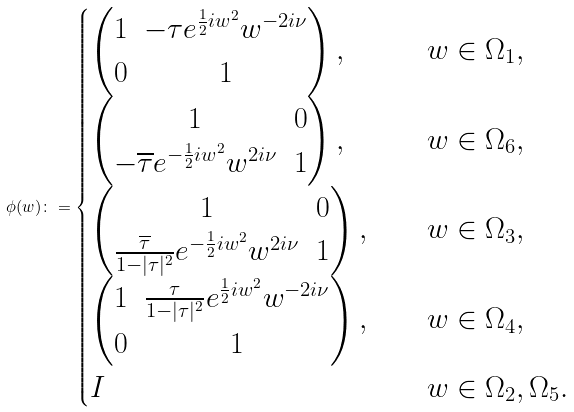Convert formula to latex. <formula><loc_0><loc_0><loc_500><loc_500>\phi ( w ) \colon = \begin{cases} \begin{pmatrix} 1 & - \tau e ^ { \frac { 1 } { 2 } i w ^ { 2 } } w ^ { - 2 i \nu } \\ 0 & 1 \end{pmatrix} , \quad & w \in \Omega _ { 1 } , \\ \begin{pmatrix} 1 & 0 \\ - \overline { \tau } e ^ { - \frac { 1 } { 2 } i w ^ { 2 } } w ^ { 2 i \nu } & 1 \end{pmatrix} , \quad & w \in \Omega _ { 6 } , \\ \begin{pmatrix} 1 & 0 \\ \frac { \overline { \tau } } { 1 - | \tau | ^ { 2 } } e ^ { - \frac { 1 } { 2 } i w ^ { 2 } } w ^ { 2 i \nu } & 1 \end{pmatrix} , \quad & w \in \Omega _ { 3 } , \\ \begin{pmatrix} 1 & \frac { \tau } { 1 - | \tau | ^ { 2 } } e ^ { \frac { 1 } { 2 } i w ^ { 2 } } w ^ { - 2 i \nu } \\ 0 & 1 \end{pmatrix} , \quad & w \in \Omega _ { 4 } , \\ I & w \in \Omega _ { 2 } , \Omega _ { 5 } . \end{cases}</formula> 